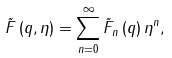<formula> <loc_0><loc_0><loc_500><loc_500>\tilde { F } \left ( q , \eta \right ) = \sum _ { n = 0 } ^ { \infty } \tilde { F } _ { n } \left ( q \right ) \eta ^ { n } ,</formula> 